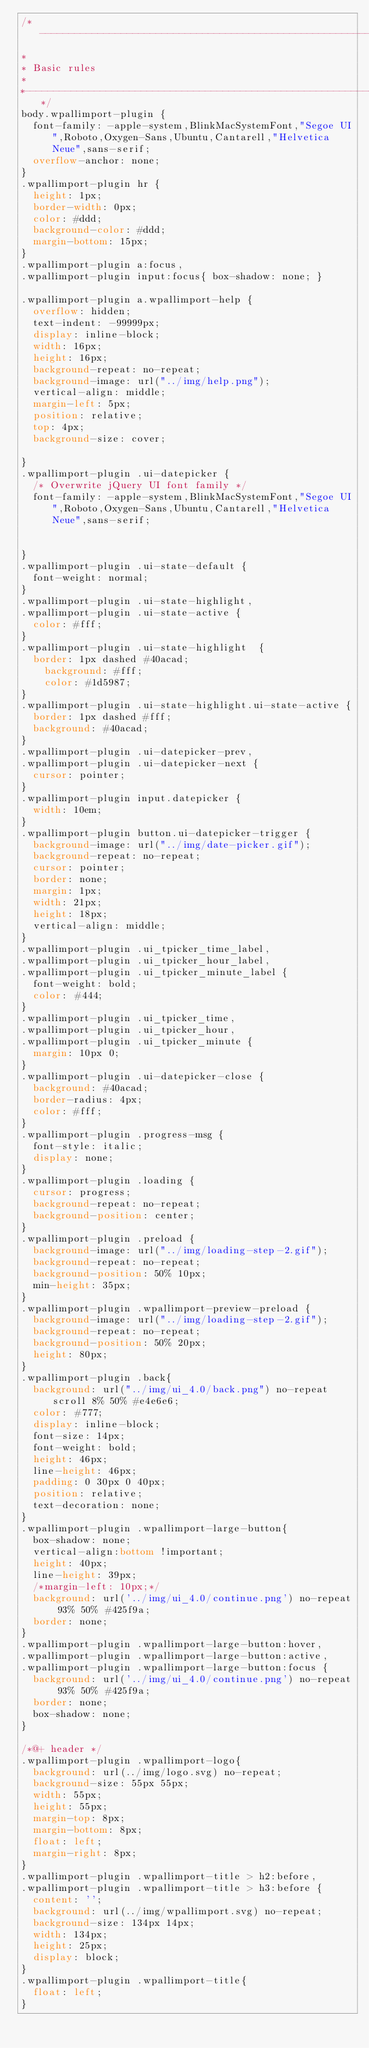Convert code to text. <code><loc_0><loc_0><loc_500><loc_500><_CSS_>/*--------------------------------------------------------------------------
*
*	Basic rules
*	
*-------------------------------------------------------------------------*/
body.wpallimport-plugin {
	font-family: -apple-system,BlinkMacSystemFont,"Segoe UI",Roboto,Oxygen-Sans,Ubuntu,Cantarell,"Helvetica Neue",sans-serif;
	overflow-anchor: none;
}
.wpallimport-plugin hr {
	height: 1px;
	border-width: 0px;
	color: #ddd;
	background-color: #ddd;
	margin-bottom: 15px;
}
.wpallimport-plugin a:focus, 
.wpallimport-plugin input:focus{ box-shadow: none; }

.wpallimport-plugin a.wpallimport-help {
	overflow: hidden;
	text-indent: -99999px;
	display: inline-block;
	width: 16px;
	height: 16px;
	background-repeat: no-repeat;
	background-image: url("../img/help.png");
	vertical-align: middle;
	margin-left: 5px;
	position: relative;
	top: 4px;
	background-size: cover;

}
.wpallimport-plugin .ui-datepicker {
	/* Overwrite jQuery UI font family */
	font-family: -apple-system,BlinkMacSystemFont,"Segoe UI",Roboto,Oxygen-Sans,Ubuntu,Cantarell,"Helvetica Neue",sans-serif;


}
.wpallimport-plugin .ui-state-default {
	font-weight: normal;
}
.wpallimport-plugin .ui-state-highlight,
.wpallimport-plugin .ui-state-active {
	color: #fff;
}
.wpallimport-plugin .ui-state-highlight  {
	border: 1px dashed #40acad;
    background: #fff;
    color: #1d5987;
}
.wpallimport-plugin .ui-state-highlight.ui-state-active {
	border: 1px dashed #fff;
	background: #40acad;
}
.wpallimport-plugin .ui-datepicker-prev,
.wpallimport-plugin .ui-datepicker-next {
	cursor: pointer;
}
.wpallimport-plugin input.datepicker {
	width: 10em;
}
.wpallimport-plugin button.ui-datepicker-trigger {
	background-image: url("../img/date-picker.gif");
	background-repeat: no-repeat;
	cursor: pointer;
	border: none;
	margin: 1px;
	width: 21px;
	height: 18px;
	vertical-align: middle;
}
.wpallimport-plugin .ui_tpicker_time_label,
.wpallimport-plugin .ui_tpicker_hour_label,
.wpallimport-plugin .ui_tpicker_minute_label {
	font-weight: bold;
	color: #444;
}
.wpallimport-plugin .ui_tpicker_time,
.wpallimport-plugin .ui_tpicker_hour,
.wpallimport-plugin .ui_tpicker_minute {
	margin: 10px 0;
}
.wpallimport-plugin .ui-datepicker-close {
	background: #40acad;
	border-radius: 4px;
	color: #fff;
}
.wpallimport-plugin .progress-msg {
	font-style: italic;
	display: none;
}
.wpallimport-plugin .loading {
	cursor: progress;
	background-repeat: no-repeat;
	background-position: center;
}
.wpallimport-plugin .preload {
	background-image: url("../img/loading-step-2.gif");
	background-repeat: no-repeat;	
	background-position: 50% 10px;
	min-height: 35px;
}
.wpallimport-plugin .wpallimport-preview-preload {
	background-image: url("../img/loading-step-2.gif");
	background-repeat: no-repeat;	
	background-position: 50% 20px;
	height: 80px;
}
.wpallimport-plugin .back{
	background: url("../img/ui_4.0/back.png") no-repeat scroll 8% 50% #e4e6e6;
	color: #777;
	display: inline-block;
	font-size: 14px;
	font-weight: bold;
	height: 46px;
	line-height: 46px;
	padding: 0 30px 0 40px;
	position: relative;
	text-decoration: none;
}
.wpallimport-plugin .wpallimport-large-button{
	box-shadow: none;
	vertical-align:bottom !important;	
	height: 40px;
	line-height: 39px;
	/*margin-left: 10px;*/
	background: url('../img/ui_4.0/continue.png') no-repeat 93% 50% #425f9a;
	border: none;
}
.wpallimport-plugin .wpallimport-large-button:hover,
.wpallimport-plugin .wpallimport-large-button:active,
.wpallimport-plugin .wpallimport-large-button:focus {
	background: url('../img/ui_4.0/continue.png') no-repeat 93% 50% #425f9a;
	border: none;
	box-shadow: none;
}

/*@+ header */
.wpallimport-plugin .wpallimport-logo{
  background: url(../img/logo.svg) no-repeat;
  background-size: 55px 55px;
  width: 55px;
  height: 55px;
  margin-top: 8px;
  margin-bottom: 8px;
  float: left;
  margin-right: 8px;
}
.wpallimport-plugin .wpallimport-title > h2:before,
.wpallimport-plugin .wpallimport-title > h3:before {
	content: '';
  background: url(../img/wpallimport.svg) no-repeat;
  background-size: 134px 14px;
  width: 134px;
  height: 25px;
  display: block;
}
.wpallimport-plugin .wpallimport-title{
	float: left;
}</code> 